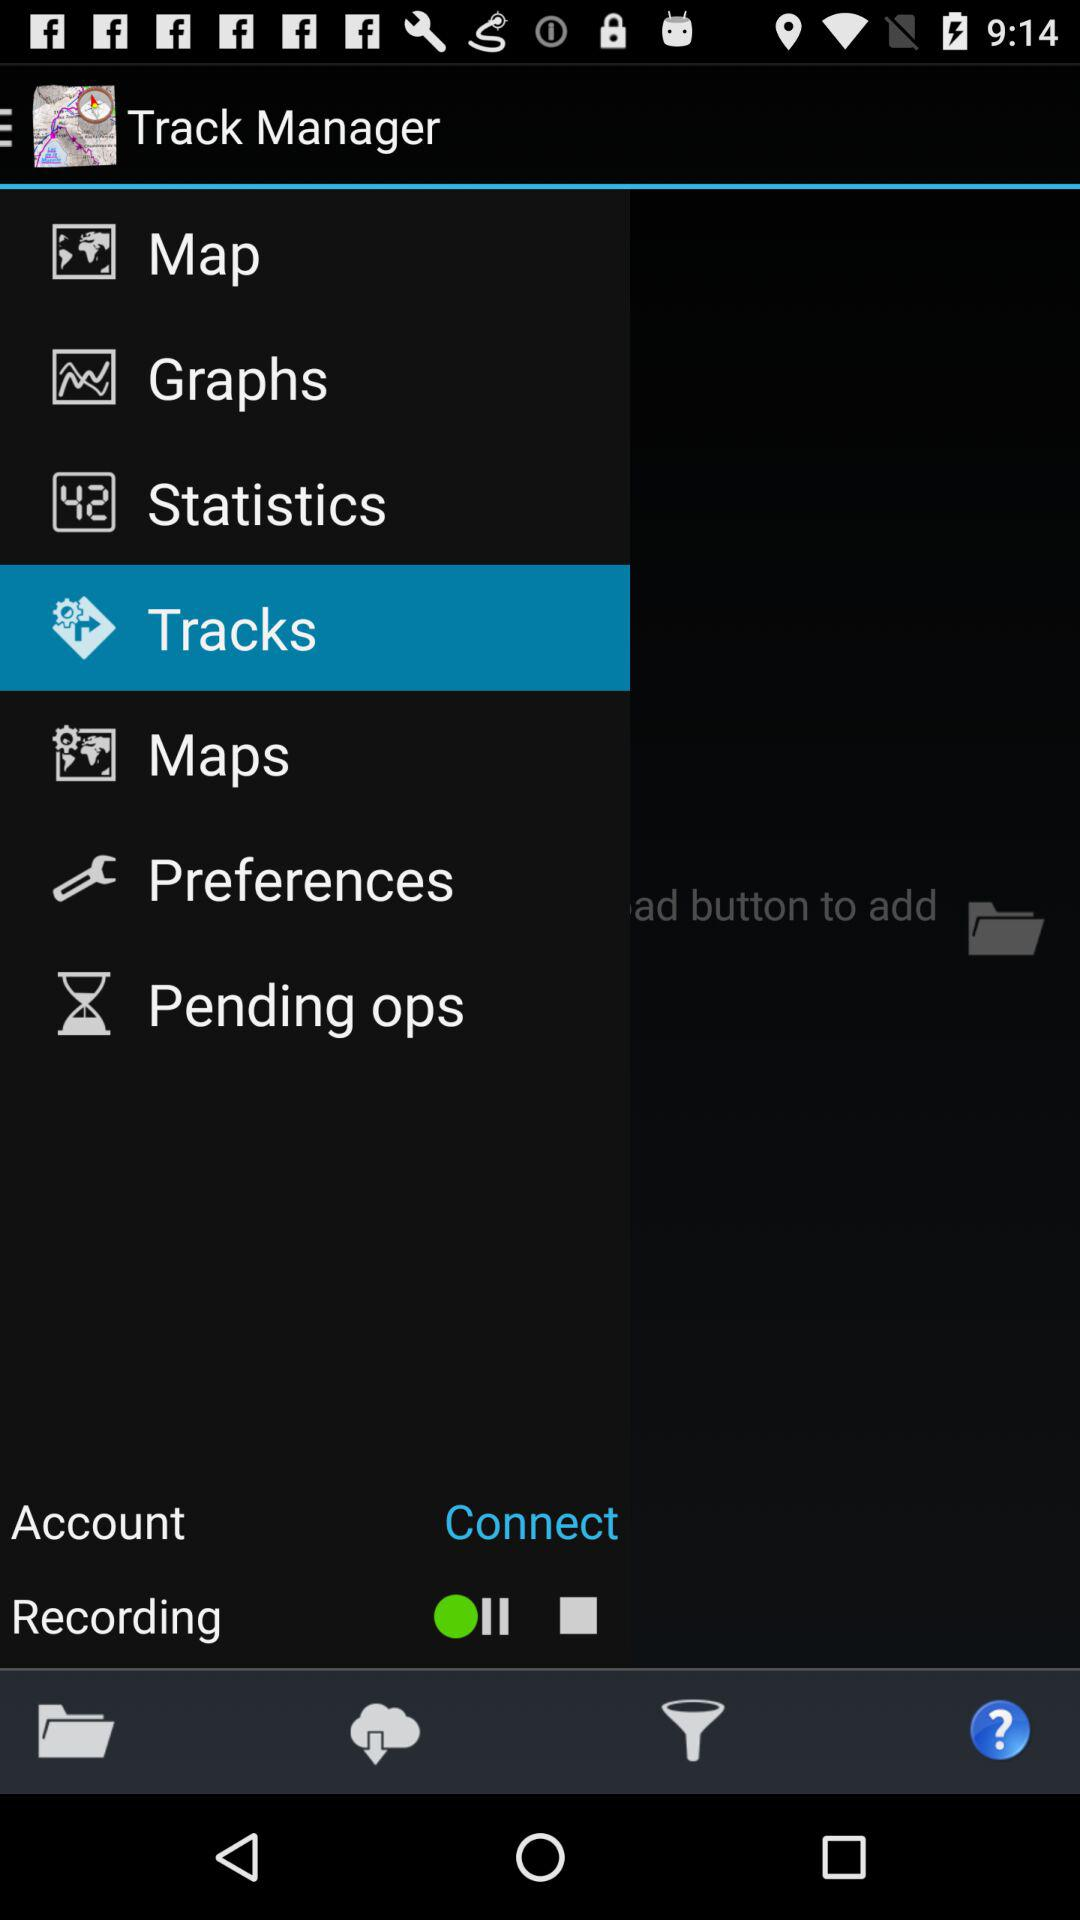What is the status of the account showing on the application?
When the provided information is insufficient, respond with <no answer>. <no answer> 